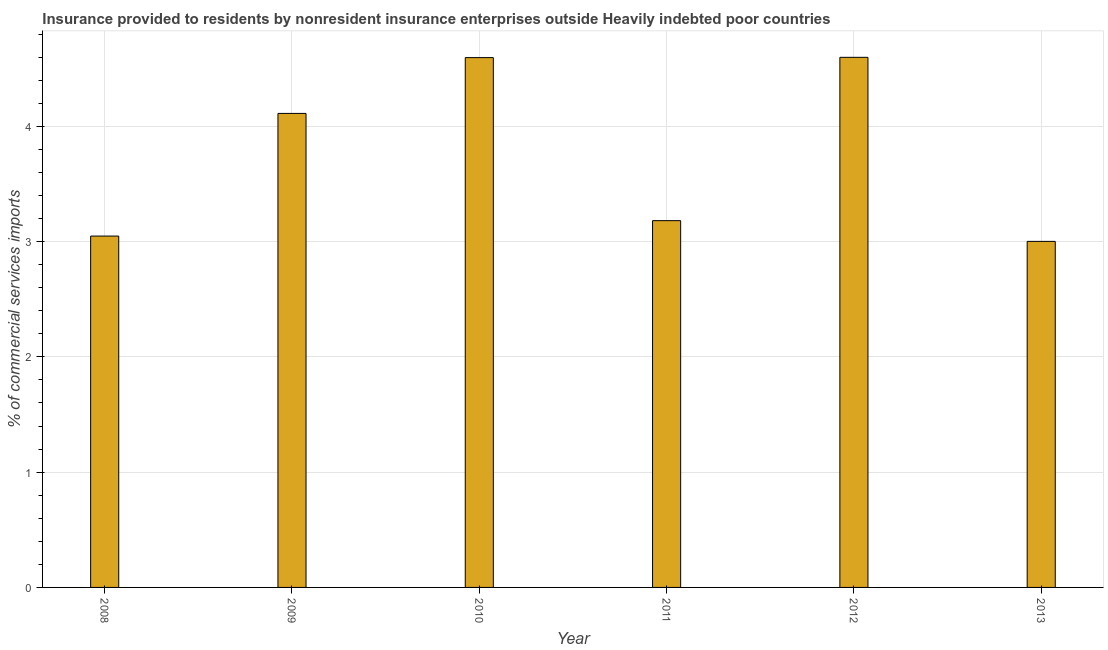What is the title of the graph?
Your response must be concise. Insurance provided to residents by nonresident insurance enterprises outside Heavily indebted poor countries. What is the label or title of the Y-axis?
Your answer should be very brief. % of commercial services imports. What is the insurance provided by non-residents in 2011?
Ensure brevity in your answer.  3.18. Across all years, what is the maximum insurance provided by non-residents?
Your answer should be compact. 4.6. Across all years, what is the minimum insurance provided by non-residents?
Keep it short and to the point. 3. What is the sum of the insurance provided by non-residents?
Offer a very short reply. 22.54. What is the difference between the insurance provided by non-residents in 2008 and 2011?
Provide a short and direct response. -0.13. What is the average insurance provided by non-residents per year?
Offer a very short reply. 3.76. What is the median insurance provided by non-residents?
Ensure brevity in your answer.  3.65. In how many years, is the insurance provided by non-residents greater than 3.8 %?
Keep it short and to the point. 3. Do a majority of the years between 2009 and 2010 (inclusive) have insurance provided by non-residents greater than 1.2 %?
Keep it short and to the point. Yes. What is the ratio of the insurance provided by non-residents in 2010 to that in 2011?
Ensure brevity in your answer.  1.44. Is the insurance provided by non-residents in 2009 less than that in 2010?
Keep it short and to the point. Yes. Is the difference between the insurance provided by non-residents in 2009 and 2013 greater than the difference between any two years?
Make the answer very short. No. What is the difference between the highest and the second highest insurance provided by non-residents?
Offer a very short reply. 0. What is the difference between the highest and the lowest insurance provided by non-residents?
Provide a succinct answer. 1.6. How many years are there in the graph?
Provide a short and direct response. 6. What is the difference between two consecutive major ticks on the Y-axis?
Your answer should be very brief. 1. Are the values on the major ticks of Y-axis written in scientific E-notation?
Offer a terse response. No. What is the % of commercial services imports in 2008?
Keep it short and to the point. 3.05. What is the % of commercial services imports of 2009?
Your answer should be compact. 4.11. What is the % of commercial services imports in 2010?
Offer a terse response. 4.6. What is the % of commercial services imports in 2011?
Keep it short and to the point. 3.18. What is the % of commercial services imports of 2012?
Give a very brief answer. 4.6. What is the % of commercial services imports in 2013?
Your answer should be compact. 3. What is the difference between the % of commercial services imports in 2008 and 2009?
Provide a succinct answer. -1.06. What is the difference between the % of commercial services imports in 2008 and 2010?
Ensure brevity in your answer.  -1.55. What is the difference between the % of commercial services imports in 2008 and 2011?
Give a very brief answer. -0.13. What is the difference between the % of commercial services imports in 2008 and 2012?
Your answer should be compact. -1.55. What is the difference between the % of commercial services imports in 2008 and 2013?
Ensure brevity in your answer.  0.05. What is the difference between the % of commercial services imports in 2009 and 2010?
Offer a terse response. -0.48. What is the difference between the % of commercial services imports in 2009 and 2011?
Give a very brief answer. 0.93. What is the difference between the % of commercial services imports in 2009 and 2012?
Offer a terse response. -0.49. What is the difference between the % of commercial services imports in 2009 and 2013?
Your response must be concise. 1.11. What is the difference between the % of commercial services imports in 2010 and 2011?
Offer a terse response. 1.41. What is the difference between the % of commercial services imports in 2010 and 2012?
Ensure brevity in your answer.  -0. What is the difference between the % of commercial services imports in 2010 and 2013?
Your response must be concise. 1.59. What is the difference between the % of commercial services imports in 2011 and 2012?
Offer a very short reply. -1.42. What is the difference between the % of commercial services imports in 2011 and 2013?
Offer a terse response. 0.18. What is the difference between the % of commercial services imports in 2012 and 2013?
Your answer should be very brief. 1.6. What is the ratio of the % of commercial services imports in 2008 to that in 2009?
Offer a very short reply. 0.74. What is the ratio of the % of commercial services imports in 2008 to that in 2010?
Your answer should be compact. 0.66. What is the ratio of the % of commercial services imports in 2008 to that in 2011?
Provide a short and direct response. 0.96. What is the ratio of the % of commercial services imports in 2008 to that in 2012?
Provide a succinct answer. 0.66. What is the ratio of the % of commercial services imports in 2009 to that in 2010?
Offer a very short reply. 0.9. What is the ratio of the % of commercial services imports in 2009 to that in 2011?
Offer a terse response. 1.29. What is the ratio of the % of commercial services imports in 2009 to that in 2012?
Provide a succinct answer. 0.89. What is the ratio of the % of commercial services imports in 2009 to that in 2013?
Your response must be concise. 1.37. What is the ratio of the % of commercial services imports in 2010 to that in 2011?
Your response must be concise. 1.44. What is the ratio of the % of commercial services imports in 2010 to that in 2013?
Your answer should be very brief. 1.53. What is the ratio of the % of commercial services imports in 2011 to that in 2012?
Offer a very short reply. 0.69. What is the ratio of the % of commercial services imports in 2011 to that in 2013?
Offer a terse response. 1.06. What is the ratio of the % of commercial services imports in 2012 to that in 2013?
Make the answer very short. 1.53. 